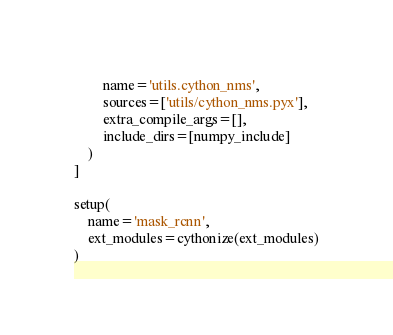<code> <loc_0><loc_0><loc_500><loc_500><_Python_>        name='utils.cython_nms',
        sources=['utils/cython_nms.pyx'],
        extra_compile_args=[],
        include_dirs=[numpy_include]
    )
]

setup(
    name='mask_rcnn',
    ext_modules=cythonize(ext_modules)
)

</code> 